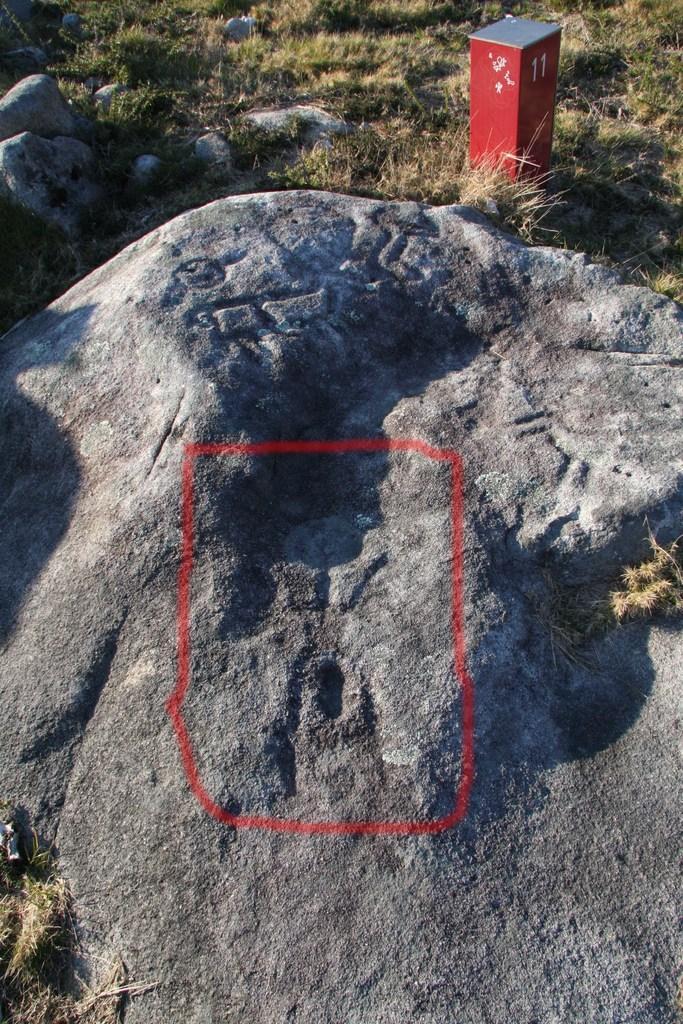Please provide a concise description of this image. In this picture we can see rocks, stone and in the background we can see grass. 